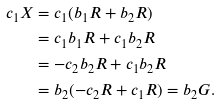Convert formula to latex. <formula><loc_0><loc_0><loc_500><loc_500>c _ { 1 } X & = c _ { 1 } ( b _ { 1 } R + b _ { 2 } R ) \\ & = c _ { 1 } b _ { 1 } R + c _ { 1 } b _ { 2 } R \\ & = - c _ { 2 } b _ { 2 } R + c _ { 1 } b _ { 2 } R \\ & = b _ { 2 } ( - c _ { 2 } R + c _ { 1 } R ) = b _ { 2 } G .</formula> 